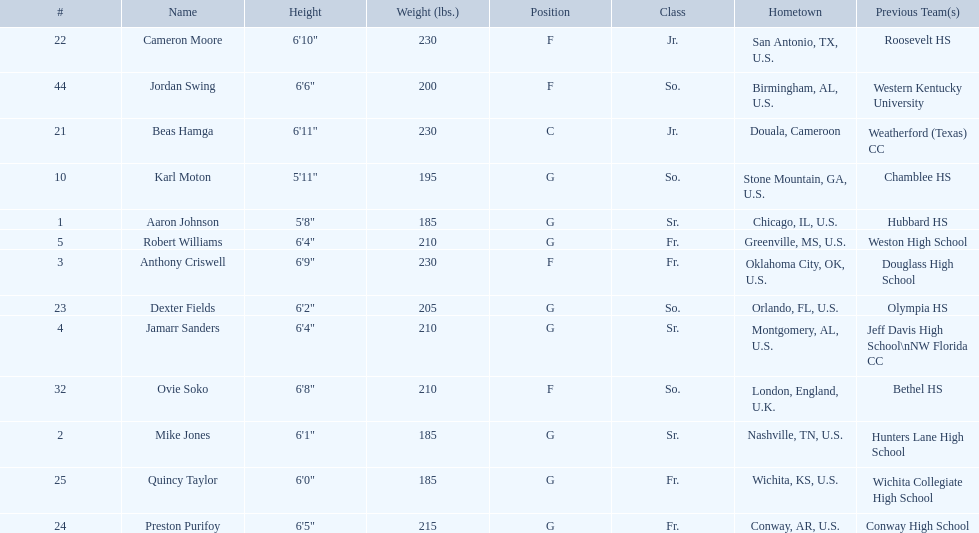Who is first on the roster? Aaron Johnson. 